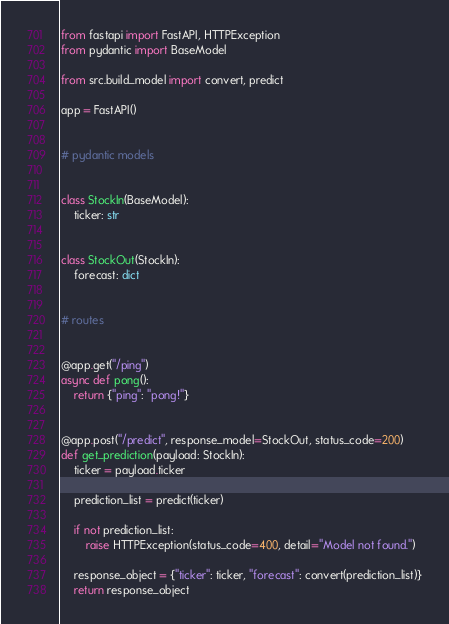Convert code to text. <code><loc_0><loc_0><loc_500><loc_500><_Python_>from fastapi import FastAPI, HTTPException
from pydantic import BaseModel

from src.build_model import convert, predict

app = FastAPI()


# pydantic models


class StockIn(BaseModel):
    ticker: str


class StockOut(StockIn):
    forecast: dict


# routes


@app.get("/ping")
async def pong():
    return {"ping": "pong!"}


@app.post("/predict", response_model=StockOut, status_code=200)
def get_prediction(payload: StockIn):
    ticker = payload.ticker

    prediction_list = predict(ticker)

    if not prediction_list:
        raise HTTPException(status_code=400, detail="Model not found.")

    response_object = {"ticker": ticker, "forecast": convert(prediction_list)}
    return response_object</code> 